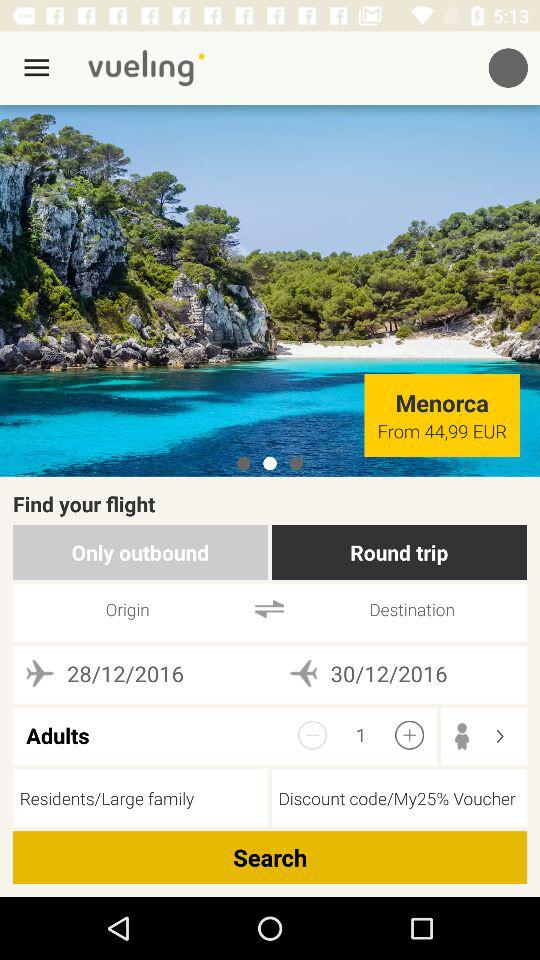What is the duration of booking?
When the provided information is insufficient, respond with <no answer>. <no answer> 